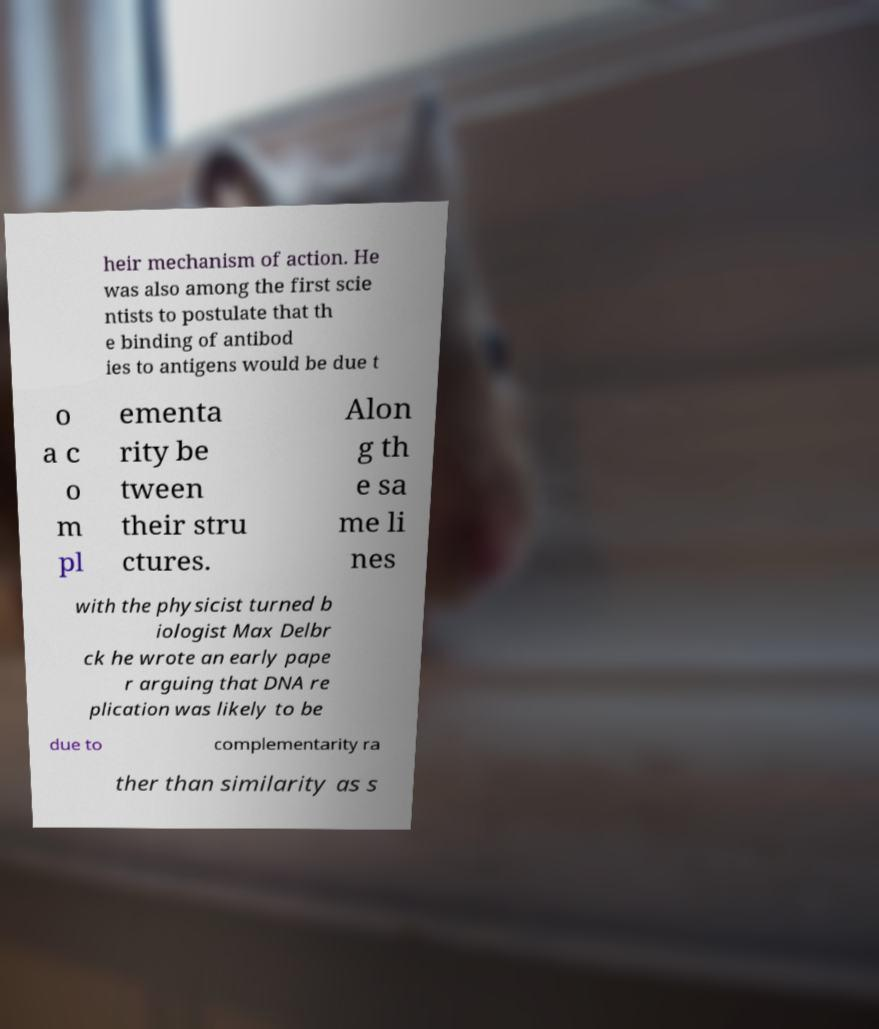Could you assist in decoding the text presented in this image and type it out clearly? heir mechanism of action. He was also among the first scie ntists to postulate that th e binding of antibod ies to antigens would be due t o a c o m pl ementa rity be tween their stru ctures. Alon g th e sa me li nes with the physicist turned b iologist Max Delbr ck he wrote an early pape r arguing that DNA re plication was likely to be due to complementarity ra ther than similarity as s 